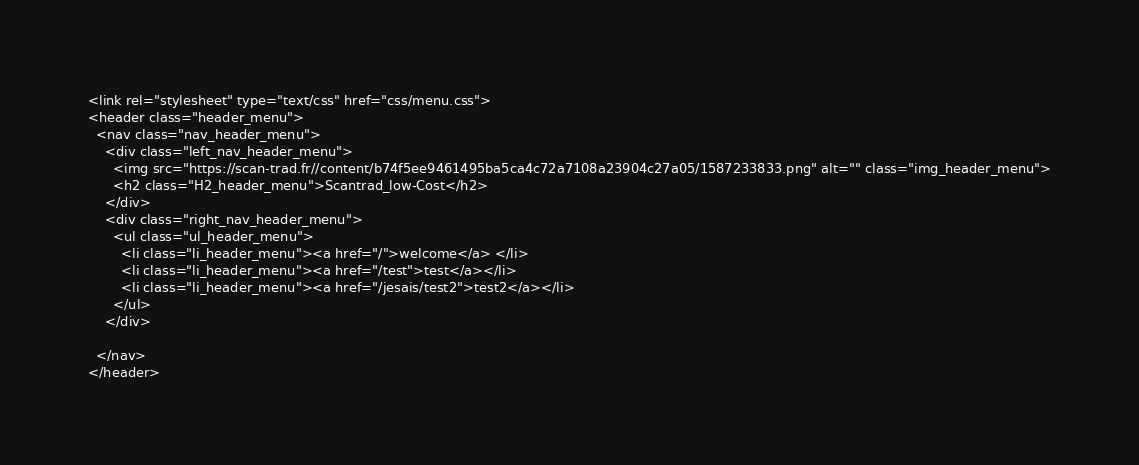<code> <loc_0><loc_0><loc_500><loc_500><_PHP_><link rel="stylesheet" type="text/css" href="css/menu.css">
<header class="header_menu">
  <nav class="nav_header_menu">
    <div class="left_nav_header_menu">
      <img src="https://scan-trad.fr//content/b74f5ee9461495ba5ca4c72a7108a23904c27a05/1587233833.png" alt="" class="img_header_menu">
      <h2 class="H2_header_menu">Scantrad_low-Cost</h2>
    </div>
    <div class="right_nav_header_menu">
      <ul class="ul_header_menu">
        <li class="li_header_menu"><a href="/">welcome</a> </li>
        <li class="li_header_menu"><a href="/test">test</a></li>
        <li class="li_header_menu"><a href="/jesais/test2">test2</a></li>
      </ul>
    </div>

  </nav>
</header>
</code> 